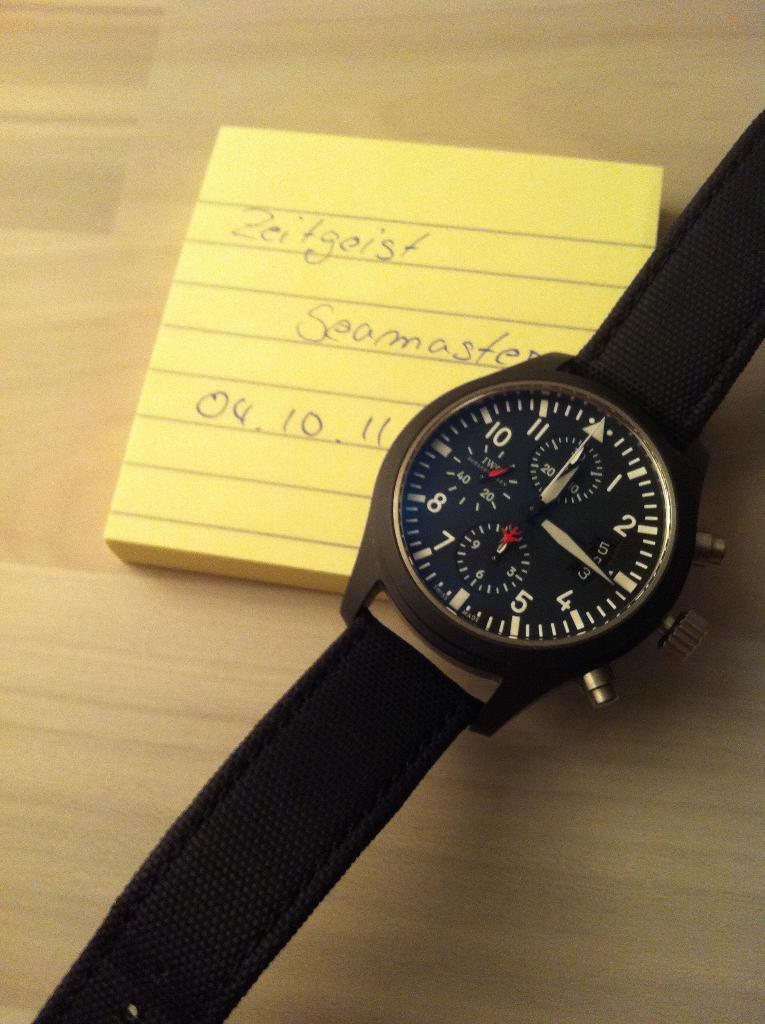<image>
Relay a brief, clear account of the picture shown. A wrist watch rests on top of a note that says Zeitgoist Seamaster. 